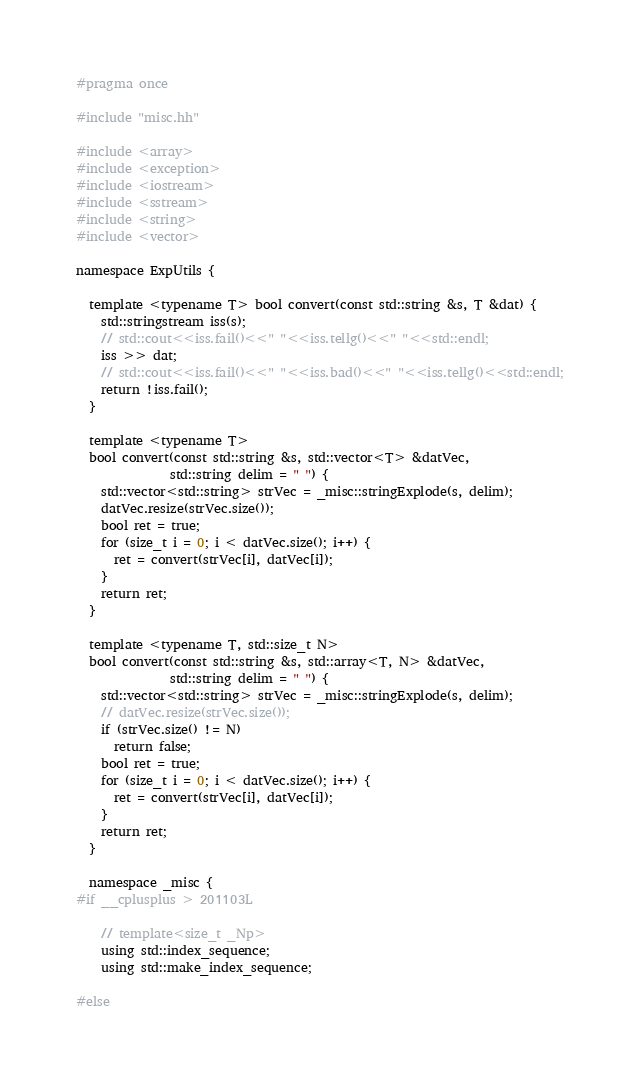Convert code to text. <code><loc_0><loc_0><loc_500><loc_500><_C++_>#pragma once

#include "misc.hh"

#include <array>
#include <exception>
#include <iostream>
#include <sstream>
#include <string>
#include <vector>

namespace ExpUtils {

  template <typename T> bool convert(const std::string &s, T &dat) {
    std::stringstream iss(s);
    // std::cout<<iss.fail()<<" "<<iss.tellg()<<" "<<std::endl;
    iss >> dat;
    // std::cout<<iss.fail()<<" "<<iss.bad()<<" "<<iss.tellg()<<std::endl;
    return !iss.fail();
  }

  template <typename T>
  bool convert(const std::string &s, std::vector<T> &datVec,
               std::string delim = " ") {
    std::vector<std::string> strVec = _misc::stringExplode(s, delim);
    datVec.resize(strVec.size());
    bool ret = true;
    for (size_t i = 0; i < datVec.size(); i++) {
      ret = convert(strVec[i], datVec[i]);
    }
    return ret;
  }

  template <typename T, std::size_t N>
  bool convert(const std::string &s, std::array<T, N> &datVec,
               std::string delim = " ") {
    std::vector<std::string> strVec = _misc::stringExplode(s, delim);
    // datVec.resize(strVec.size());
    if (strVec.size() != N)
      return false;
    bool ret = true;
    for (size_t i = 0; i < datVec.size(); i++) {
      ret = convert(strVec[i], datVec[i]);
    }
    return ret;
  }

  namespace _misc {
#if __cplusplus > 201103L

    // template<size_t _Np>
    using std::index_sequence;
    using std::make_index_sequence;

#else</code> 